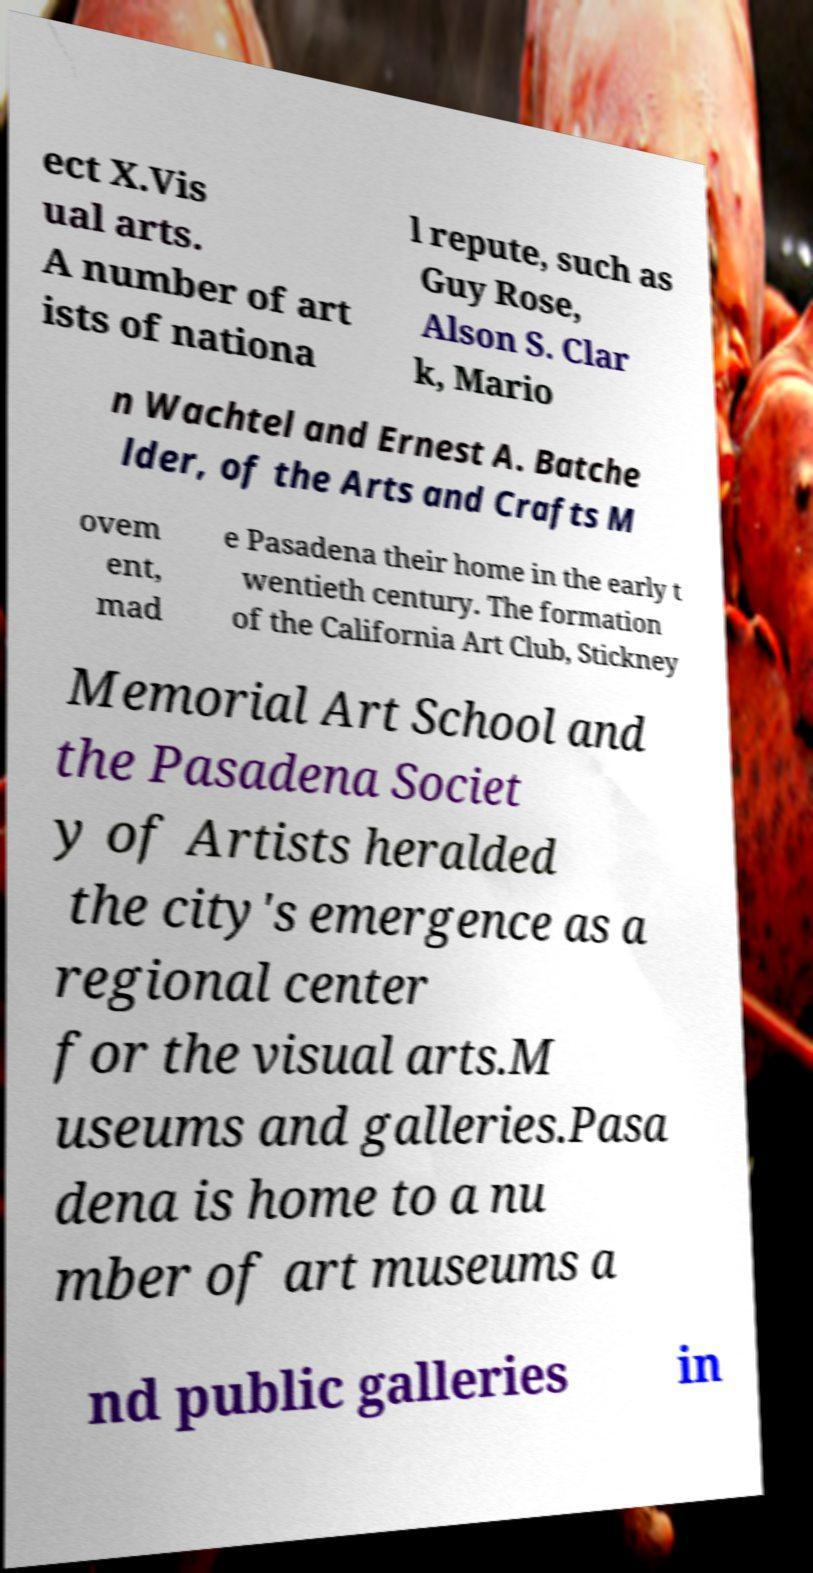Could you extract and type out the text from this image? ect X.Vis ual arts. A number of art ists of nationa l repute, such as Guy Rose, Alson S. Clar k, Mario n Wachtel and Ernest A. Batche lder, of the Arts and Crafts M ovem ent, mad e Pasadena their home in the early t wentieth century. The formation of the California Art Club, Stickney Memorial Art School and the Pasadena Societ y of Artists heralded the city's emergence as a regional center for the visual arts.M useums and galleries.Pasa dena is home to a nu mber of art museums a nd public galleries in 